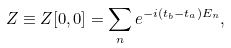<formula> <loc_0><loc_0><loc_500><loc_500>Z \equiv Z [ 0 , 0 ] = \sum _ { n } e ^ { - i ( t _ { b } - t _ { a } ) E _ { n } } ,</formula> 